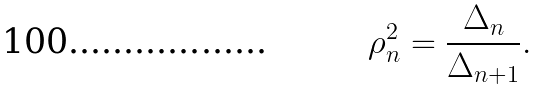<formula> <loc_0><loc_0><loc_500><loc_500>\rho _ { n } ^ { 2 } = \frac { \Delta _ { n } } { \Delta _ { n + 1 } } .</formula> 